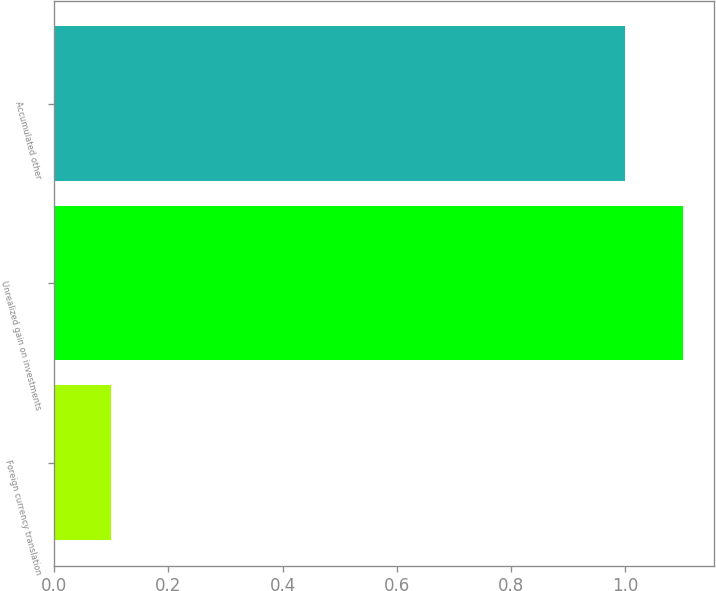<chart> <loc_0><loc_0><loc_500><loc_500><bar_chart><fcel>Foreign currency translation<fcel>Unrealized gain on investments<fcel>Accumulated other<nl><fcel>0.1<fcel>1.1<fcel>1<nl></chart> 